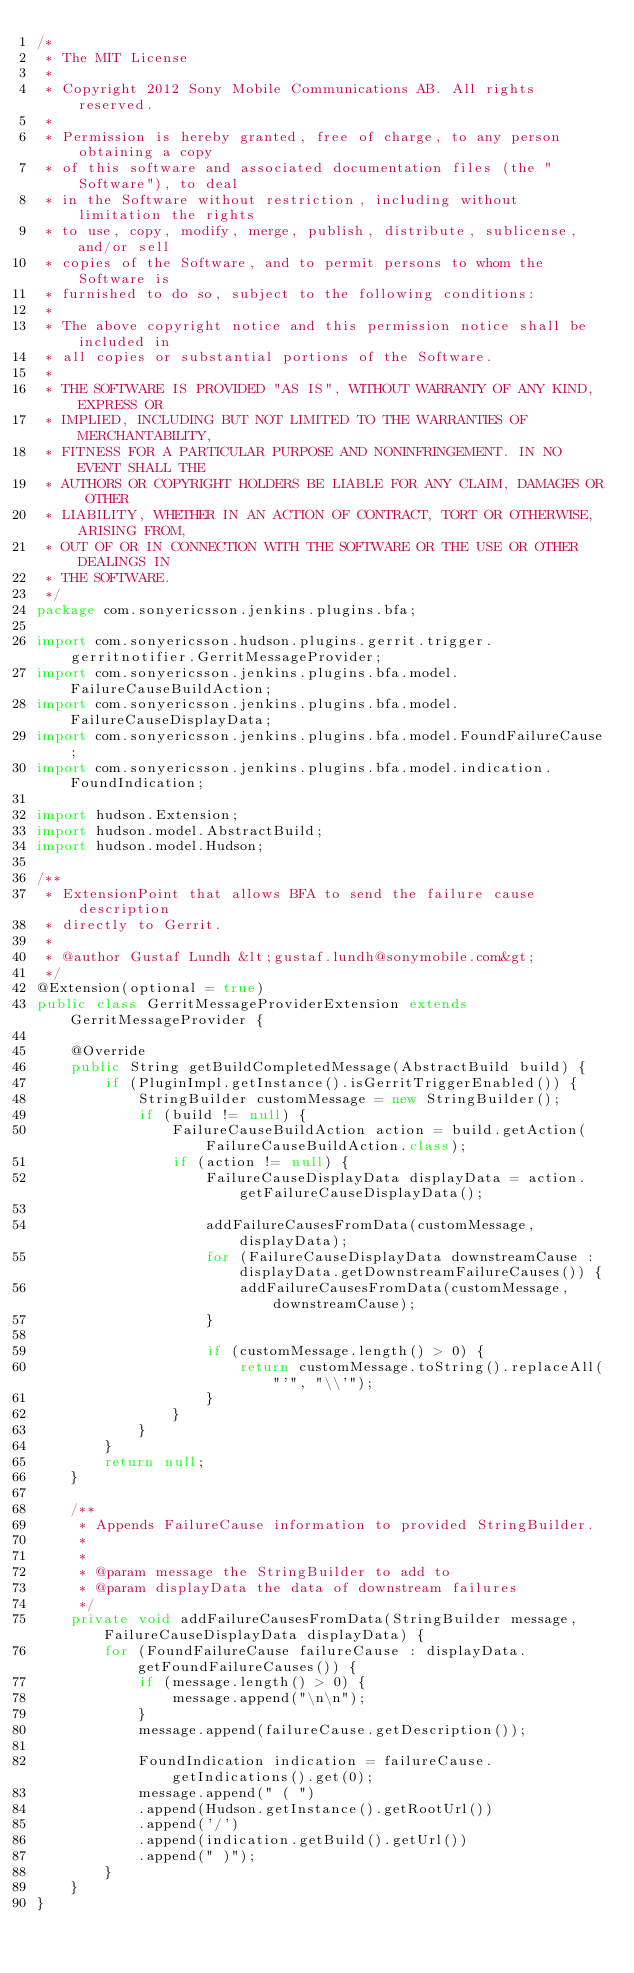Convert code to text. <code><loc_0><loc_0><loc_500><loc_500><_Java_>/*
 * The MIT License
 *
 * Copyright 2012 Sony Mobile Communications AB. All rights reserved.
 *
 * Permission is hereby granted, free of charge, to any person obtaining a copy
 * of this software and associated documentation files (the "Software"), to deal
 * in the Software without restriction, including without limitation the rights
 * to use, copy, modify, merge, publish, distribute, sublicense, and/or sell
 * copies of the Software, and to permit persons to whom the Software is
 * furnished to do so, subject to the following conditions:
 *
 * The above copyright notice and this permission notice shall be included in
 * all copies or substantial portions of the Software.
 *
 * THE SOFTWARE IS PROVIDED "AS IS", WITHOUT WARRANTY OF ANY KIND, EXPRESS OR
 * IMPLIED, INCLUDING BUT NOT LIMITED TO THE WARRANTIES OF MERCHANTABILITY,
 * FITNESS FOR A PARTICULAR PURPOSE AND NONINFRINGEMENT. IN NO EVENT SHALL THE
 * AUTHORS OR COPYRIGHT HOLDERS BE LIABLE FOR ANY CLAIM, DAMAGES OR OTHER
 * LIABILITY, WHETHER IN AN ACTION OF CONTRACT, TORT OR OTHERWISE, ARISING FROM,
 * OUT OF OR IN CONNECTION WITH THE SOFTWARE OR THE USE OR OTHER DEALINGS IN
 * THE SOFTWARE.
 */
package com.sonyericsson.jenkins.plugins.bfa;

import com.sonyericsson.hudson.plugins.gerrit.trigger.gerritnotifier.GerritMessageProvider;
import com.sonyericsson.jenkins.plugins.bfa.model.FailureCauseBuildAction;
import com.sonyericsson.jenkins.plugins.bfa.model.FailureCauseDisplayData;
import com.sonyericsson.jenkins.plugins.bfa.model.FoundFailureCause;
import com.sonyericsson.jenkins.plugins.bfa.model.indication.FoundIndication;

import hudson.Extension;
import hudson.model.AbstractBuild;
import hudson.model.Hudson;

/**
 * ExtensionPoint that allows BFA to send the failure cause description
 * directly to Gerrit.
 *
 * @author Gustaf Lundh &lt;gustaf.lundh@sonymobile.com&gt;
 */
@Extension(optional = true)
public class GerritMessageProviderExtension extends GerritMessageProvider {

    @Override
    public String getBuildCompletedMessage(AbstractBuild build) {
        if (PluginImpl.getInstance().isGerritTriggerEnabled()) {
            StringBuilder customMessage = new StringBuilder();
            if (build != null) {
                FailureCauseBuildAction action = build.getAction(FailureCauseBuildAction.class);
                if (action != null) {
                    FailureCauseDisplayData displayData = action.getFailureCauseDisplayData();

                    addFailureCausesFromData(customMessage, displayData);
                    for (FailureCauseDisplayData downstreamCause : displayData.getDownstreamFailureCauses()) {
                        addFailureCausesFromData(customMessage, downstreamCause);
                    }

                    if (customMessage.length() > 0) {
                        return customMessage.toString().replaceAll("'", "\\'");
                    }
                }
            }
        }
        return null;
    }

    /**
     * Appends FailureCause information to provided StringBuilder.
     *
     *
     * @param message the StringBuilder to add to
     * @param displayData the data of downstream failures
     */
    private void addFailureCausesFromData(StringBuilder message, FailureCauseDisplayData displayData) {
        for (FoundFailureCause failureCause : displayData.getFoundFailureCauses()) {
            if (message.length() > 0) {
                message.append("\n\n");
            }
            message.append(failureCause.getDescription());

            FoundIndication indication = failureCause.getIndications().get(0);
            message.append(" ( ")
            .append(Hudson.getInstance().getRootUrl())
            .append('/')
            .append(indication.getBuild().getUrl())
            .append(" )");
        }
    }
}
</code> 